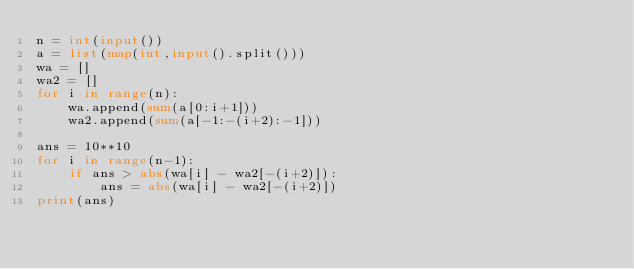<code> <loc_0><loc_0><loc_500><loc_500><_Python_>n = int(input())
a = list(map(int,input().split()))
wa = []
wa2 = []
for i in range(n):
    wa.append(sum(a[0:i+1]))
    wa2.append(sum(a[-1:-(i+2):-1]))
 
ans = 10**10
for i in range(n-1):
    if ans > abs(wa[i] - wa2[-(i+2)]):
        ans = abs(wa[i] - wa2[-(i+2)])
print(ans)</code> 